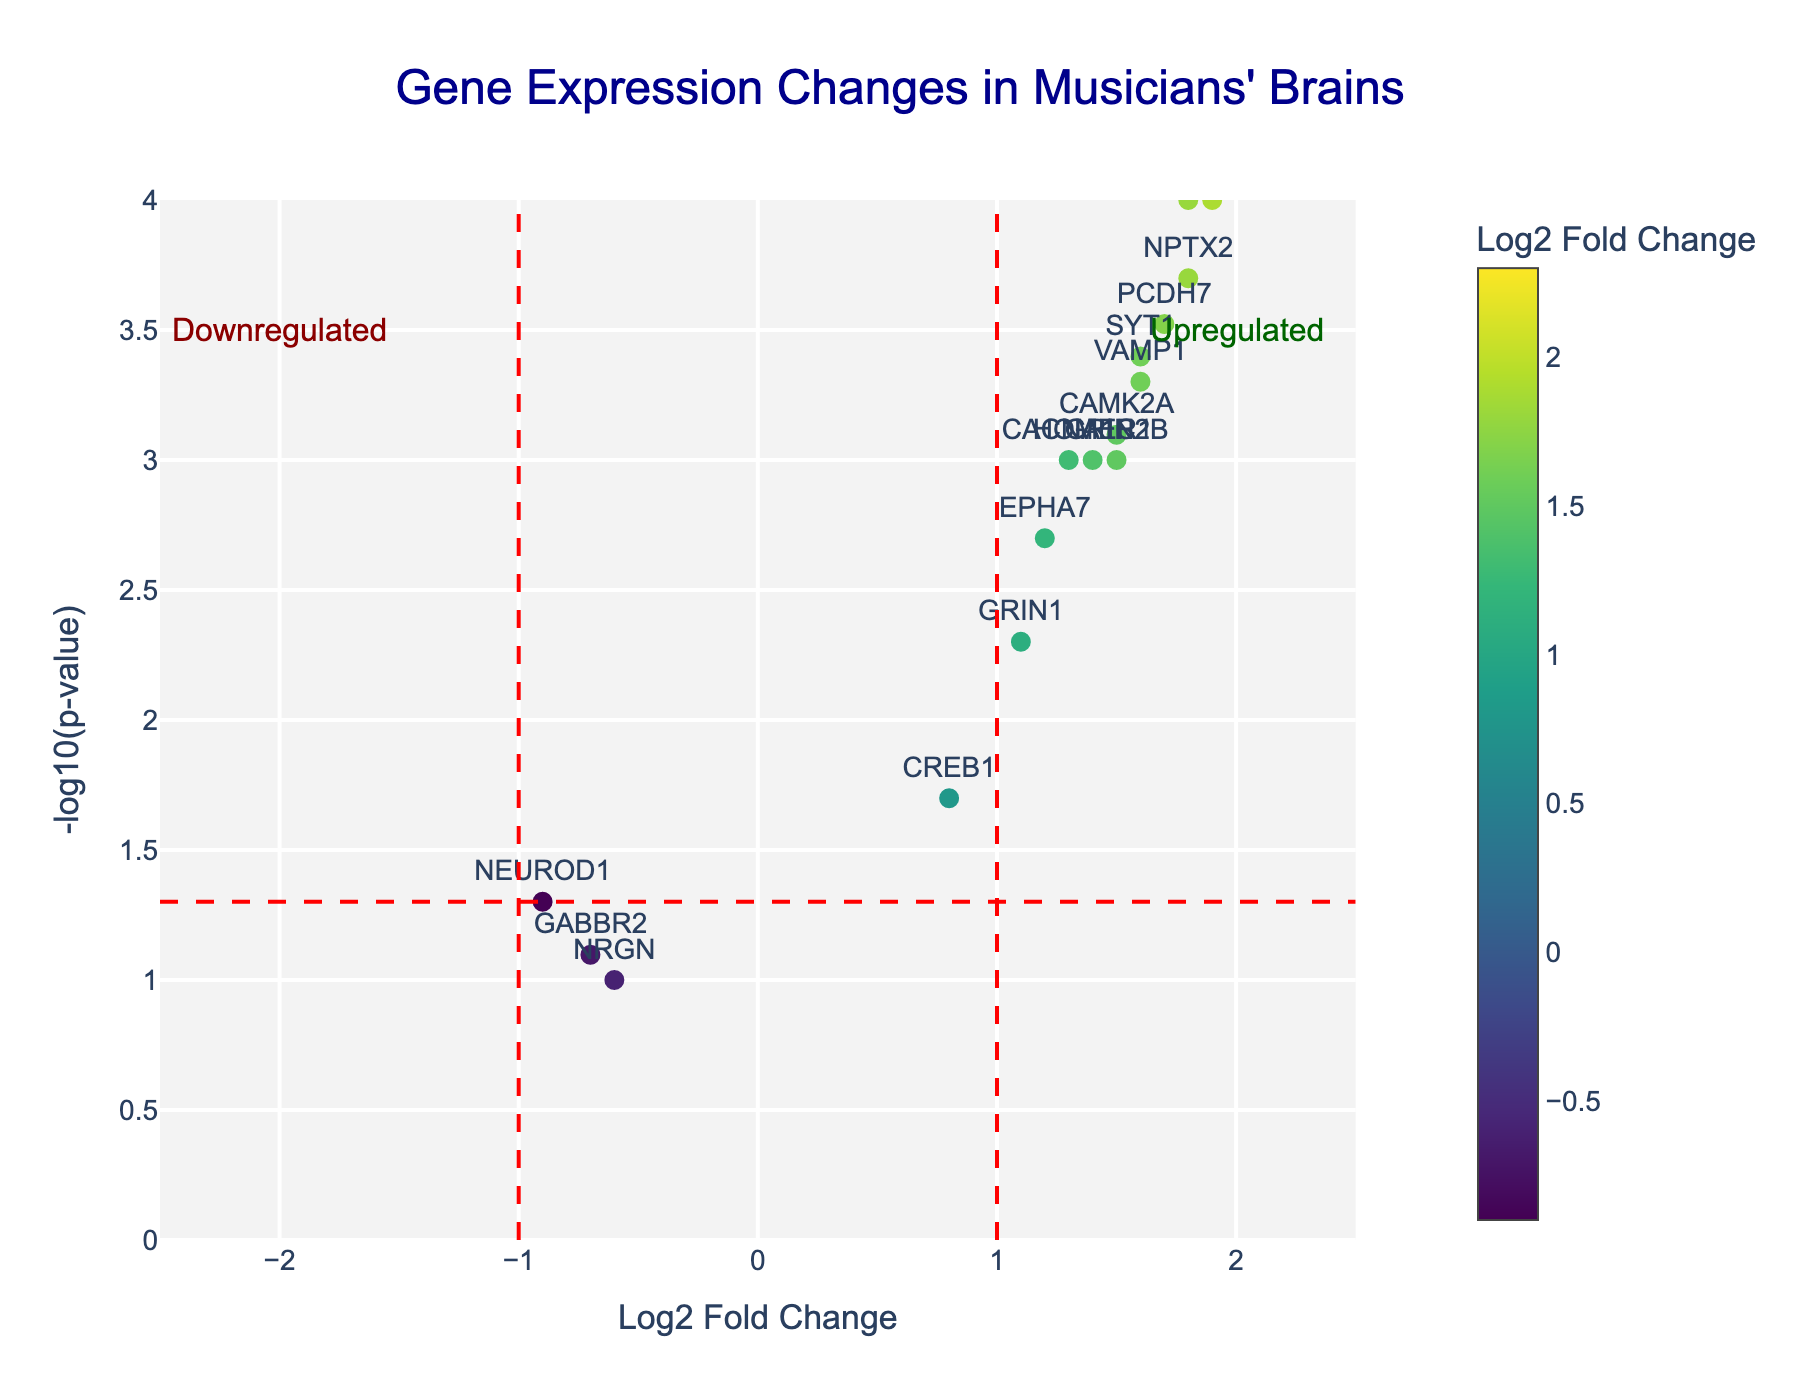How many genes are represented in the plot? To find the number of genes represented in the plot, count every distinct data point labeled with a gene name. There are 20 distinct gene names in the data.
Answer: 20 Which gene shows the highest log2 fold change and what is its corresponding p-value? To determine the gene with the highest log2 fold change, identify the gene with the highest x-axis value, which is CNTNAP2 with a logFC of 2.3. The corresponding p-value for CNTNAP2 is 0.00005.
Answer: CNTNAP2, 0.00005 Describe the meaning of the red dashed lines on the plot. The red dashed vertical lines at logFC = -1 and logFC = 1 indicate the threshold for significant downregulation and upregulation, respectively. The horizontal red dashed line represents the significance threshold for p-value (0.05), corresponding to -log10(0.05).
Answer: Thresholds for significance How many genes are significantly upregulated (logFC > 1 and p-value < 0.05)? To find the number of significantly upregulated genes, identify genes with logFC > 1 and p-value < 0.05. From the data, 13 genes (FOXP2, CNTNAP2, GRIN2B, BDNF, PCDH7, NRXN1, VAMP1, SLC6A4, CACNA1C, NPTX2, HOMER1, CAMK2A, ARC) meet this criterion.
Answer: 13 Which gene is most significantly associated with musicians based on the p-value? To find the most significant gene based on the p-value, identify the gene with the smallest p-value. ARC and SLC6A4 both have the smallest p-value of 0.00001.
Answer: ARC and SLC6A4 What does a negative logFC indicate about the gene expression? A negative logFC indicates downregulation, meaning that the gene's expression levels are lower in musicians' brains compared to non-musicians' brains.
Answer: Downregulation Which gene is closest to the vertical line at logFC = -1? To find the gene closest to logFC = -1, look at the x-axis values near -1. NEUROD1, with a logFC of -0.9, is closest to the line at logFC = -1.
Answer: NEUROD1 What is the approximate -log10(p-value) threshold for significance? The approximate -log10(p-value) threshold for significance can be identified by the horizontal red dashed line. For a p-value of 0.05, -log10(0.05) is approximately 1.3.
Answer: 1.3 Compare the logFC values of FOXP2 and VAMP1. Which one is higher? To compare the logFC values of FOXP2 and VAMP1, look at their x-axis values. FOXP2 has a logFC of 1.8, and VAMP1 has a logFC of 1.6. Therefore, FOXP2 has a higher logFC.
Answer: FOXP2 